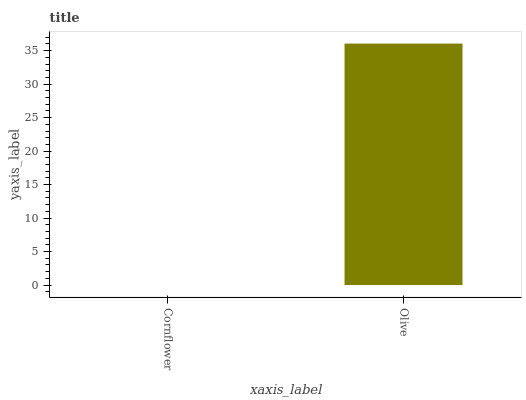Is Cornflower the minimum?
Answer yes or no. Yes. Is Olive the maximum?
Answer yes or no. Yes. Is Olive the minimum?
Answer yes or no. No. Is Olive greater than Cornflower?
Answer yes or no. Yes. Is Cornflower less than Olive?
Answer yes or no. Yes. Is Cornflower greater than Olive?
Answer yes or no. No. Is Olive less than Cornflower?
Answer yes or no. No. Is Olive the high median?
Answer yes or no. Yes. Is Cornflower the low median?
Answer yes or no. Yes. Is Cornflower the high median?
Answer yes or no. No. Is Olive the low median?
Answer yes or no. No. 